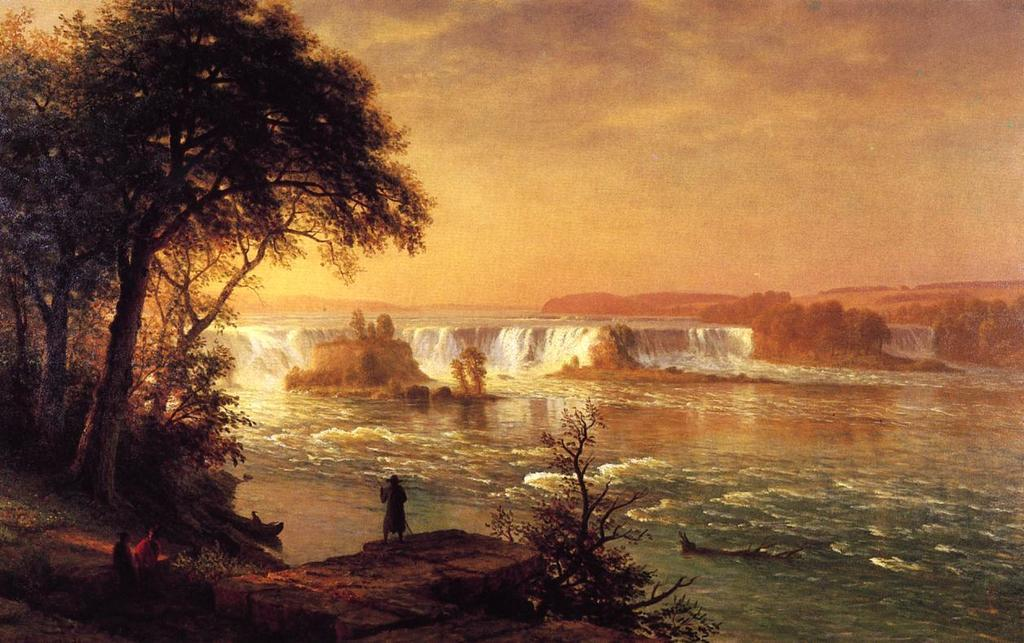Who or what can be seen in the image? There are people in the image. What type of natural elements are present in the image? There are trees, water, and plants visible in the image. What is visible in the background of the image? The sky is visible in the background of the image. What can be observed in the sky? Clouds are present in the sky. How many eggs are being used as a unit of measurement in the image? There are no eggs present in the image, and therefore no such measurement can be observed. 